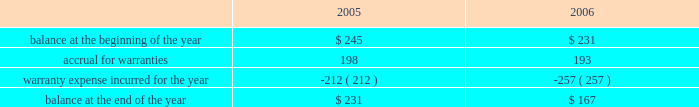Abiomed , inc .
And subsidiaries notes to consolidated financial statements 2014 ( continued ) evidence of an arrangement exists , ( 2 ) delivery has occurred or services have been rendered , ( 3 ) the seller 2019s price to the buyer is fixed or determinable , and ( 4 ) collectibility is reasonably assured .
Further , sab 104 requires that both title and the risks and rewards of ownership be transferred to the buyer before revenue can be recognized .
In addition to sab 104 , we follow the guidance of eitf 00-21 , revenue arrangements with multiple deliverables .
We derive our revenues primarily from product sales , including maintenance service agreements .
The great majority of our product revenues are derived from shipments of our ab5000 and bvs 5000 product lines to fulfill customer orders for a specified number of consoles and/or blood pumps for a specified price .
We recognize revenues and record costs related to such sales upon product shipment .
Maintenance and service support contract revenues are recognized ratably over the term of the service contracts based upon the elapsed term of the service contract .
Government-sponsored research and development contracts and grants generally provide for payment on a cost-plus-fixed-fee basis .
Revenues from these contracts and grants are recognized as work is performed , provided the government has appropriated sufficient funds for the work .
Under contracts in which the company elects to spend significantly more on the development project during the term of the contract than the total contract amount , the company prospectively recognizes revenue on such contracts ratably over the term of the contract as it incurs related research and development costs , provided the government has appropriated sufficient funds for the work .
( d ) translation of foreign currencies all assets and liabilities of the company 2019s non-u.s .
Subsidiaries are translated at year-end exchange rates , and revenues and expenses are translated at average exchange rates for the year in accordance with sfas no .
52 , foreign currency translation .
Resulting translation adjustments are reflected in the accumulated other comprehensive loss component of shareholders 2019 equity .
Currency transaction gains and losses are included in the accompanying statement of income and are not material for the three years presented .
( e ) warranties the company routinely accrues for estimated future warranty costs on its product sales at the time of sale .
Our products are subject to rigorous regulation and quality standards .
Warranty costs are included in cost of product revenues within the consolidated statements of operations .
The table summarizes the activities in the warranty reserve for the two fiscal years ended march 31 , 2006 ( in thousands ) .

Assuming a similar change in warranty expense as in 2006 , what would the 2007 expense provision ( 000 ) ? 
Computations: (257 + (257 - 212))
Answer: 302.0. 